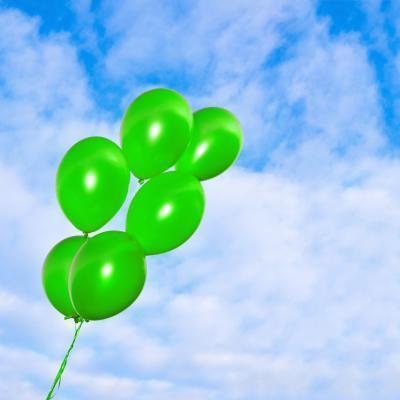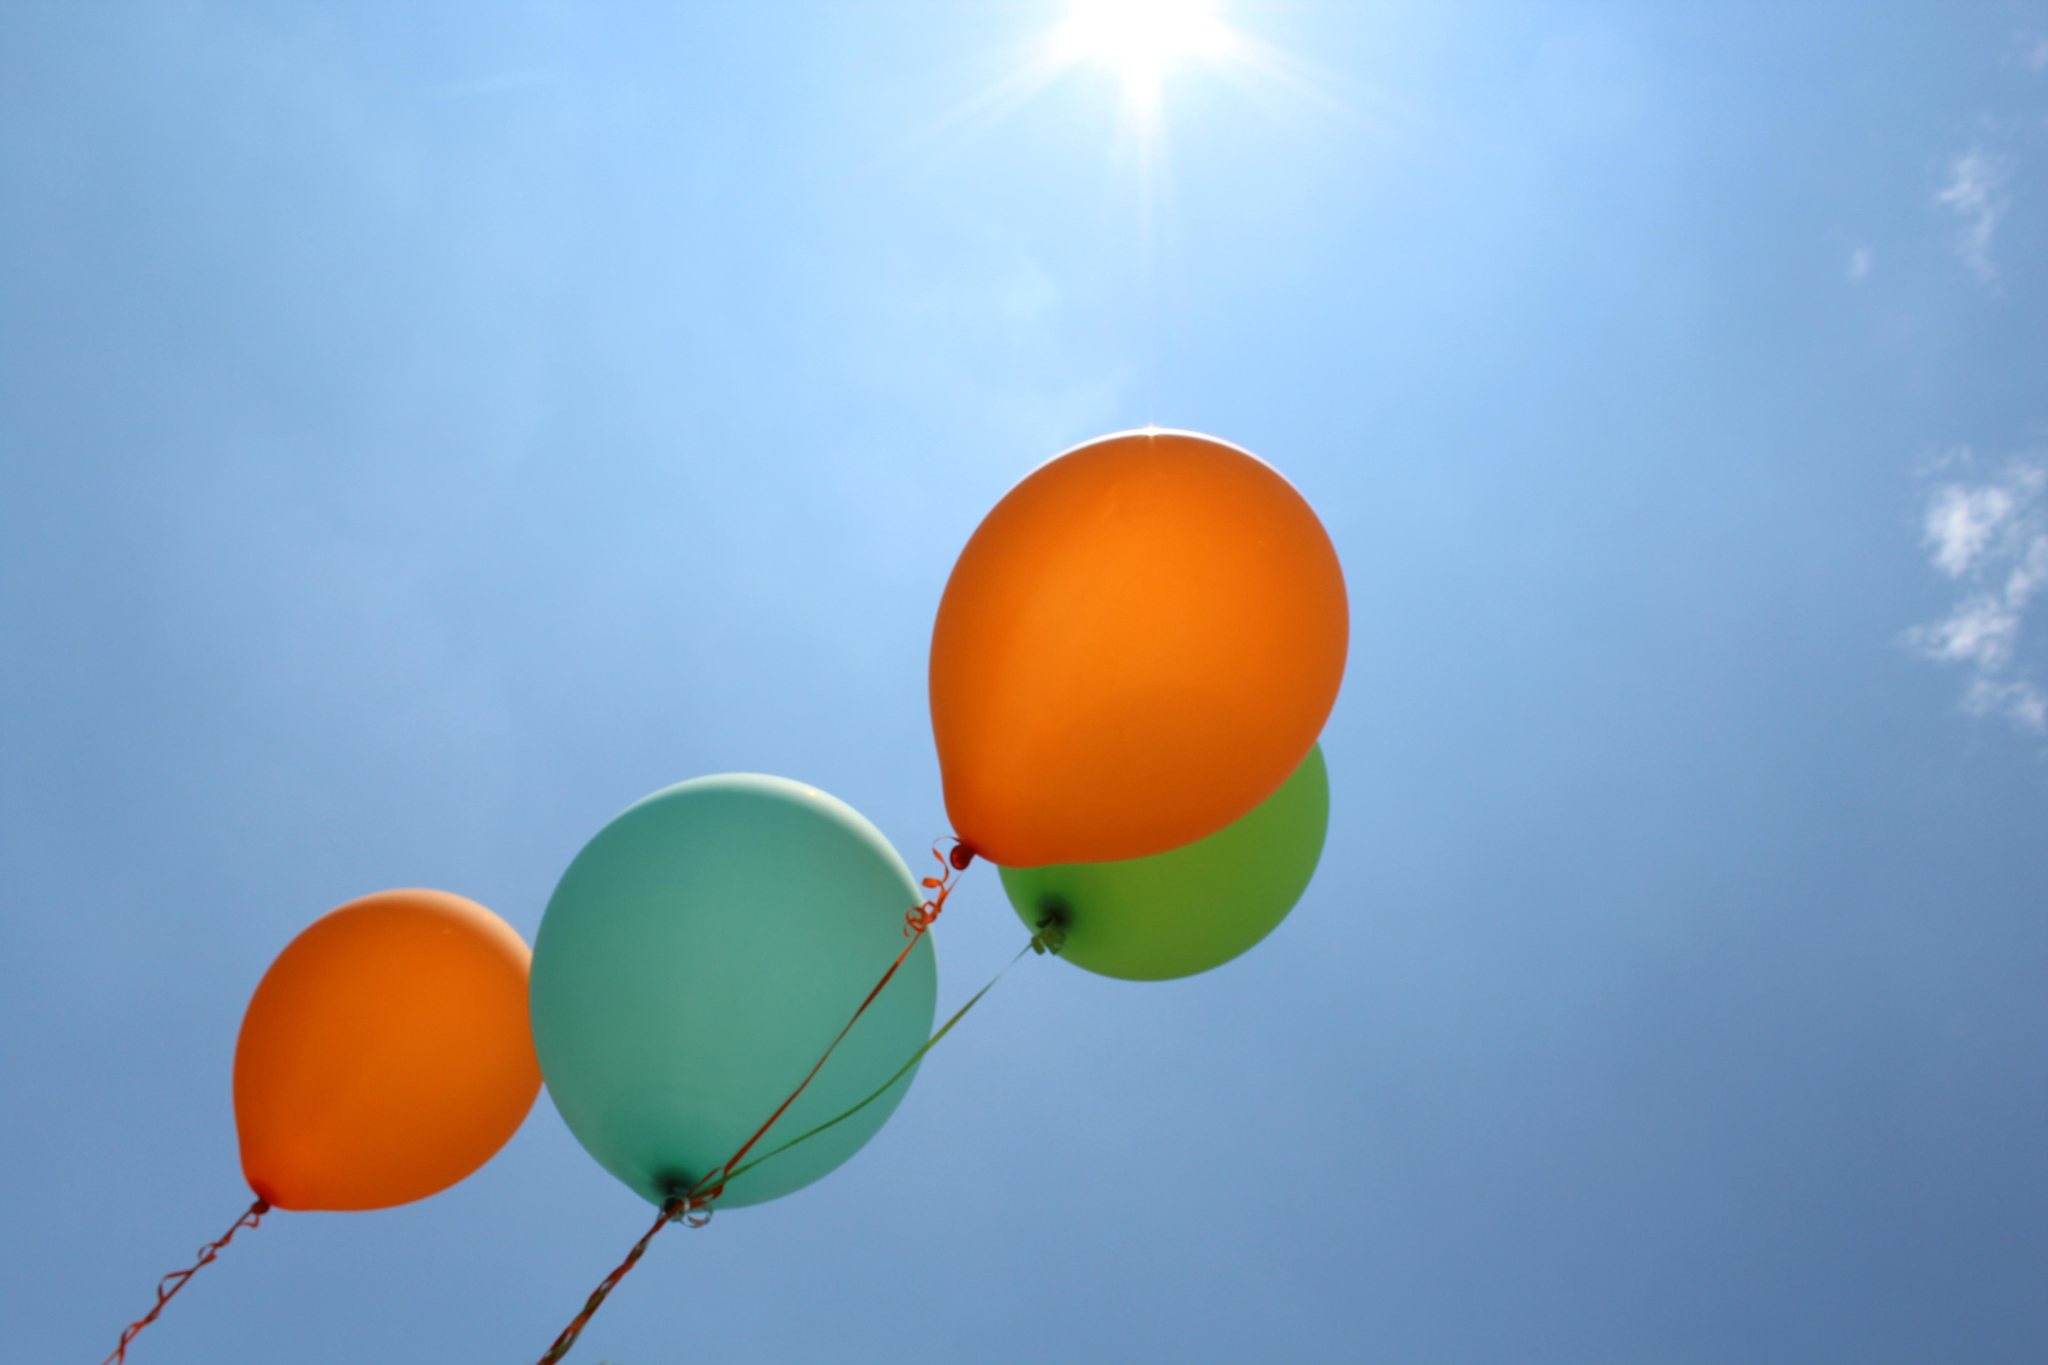The first image is the image on the left, the second image is the image on the right. Assess this claim about the two images: "An image contains exactly two yellowish balloons against a cloud-scattered blue sky.". Correct or not? Answer yes or no. No. The first image is the image on the left, the second image is the image on the right. For the images displayed, is the sentence "In at least one of the pictures, all of the balloons are yellow." factually correct? Answer yes or no. No. 